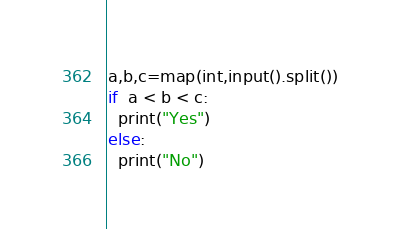<code> <loc_0><loc_0><loc_500><loc_500><_Python_>a,b,c=map(int,input().split())
if  a < b < c:
  print("Yes")
else:
  print("No")
</code> 